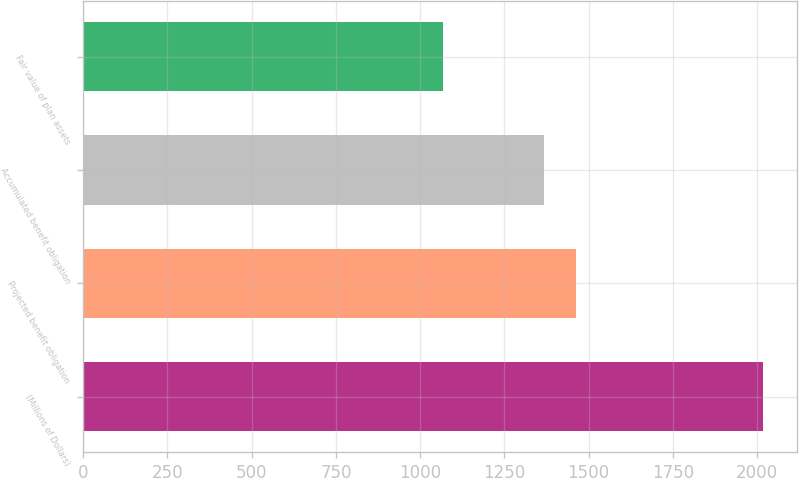Convert chart. <chart><loc_0><loc_0><loc_500><loc_500><bar_chart><fcel>(Millions of Dollars)<fcel>Projected benefit obligation<fcel>Accumulated benefit obligation<fcel>Fair value of plan assets<nl><fcel>2017<fcel>1463.55<fcel>1368.7<fcel>1068.5<nl></chart> 